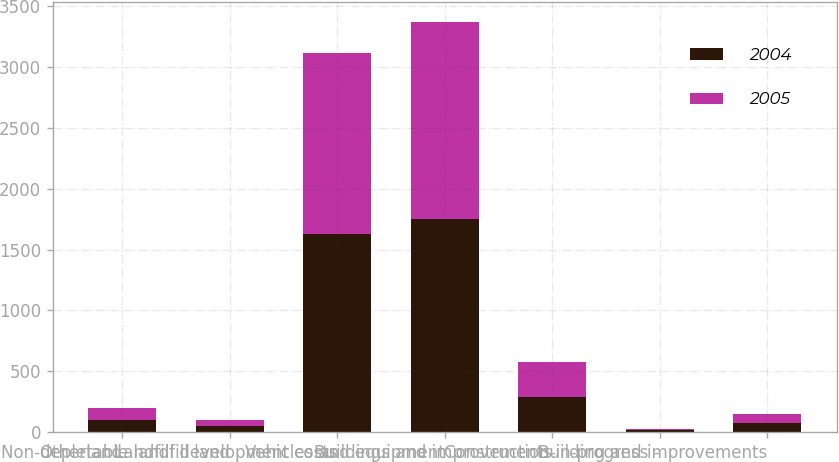Convert chart. <chart><loc_0><loc_0><loc_500><loc_500><stacked_bar_chart><ecel><fcel>Otherland<fcel>Non-depletable landfill land<fcel>Landfill development costs<fcel>Vehicles and equipment<fcel>Buildings and improvements<fcel>Construction-in-progress -<fcel>Building and improvements<nl><fcel>2004<fcel>100.9<fcel>51.6<fcel>1630<fcel>1746.8<fcel>287.1<fcel>18<fcel>80.3<nl><fcel>2005<fcel>97.9<fcel>53.4<fcel>1486.5<fcel>1617.5<fcel>287<fcel>7.4<fcel>70.8<nl></chart> 